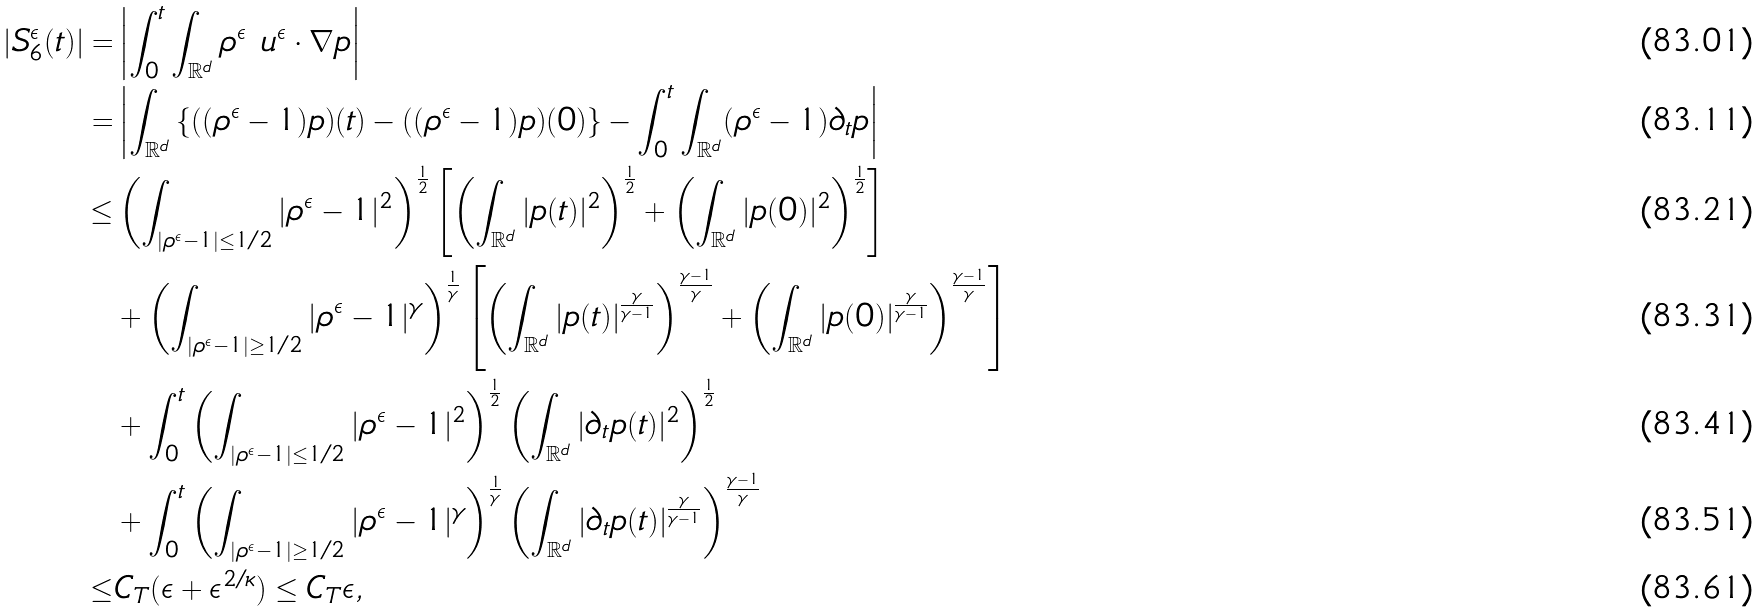<formula> <loc_0><loc_0><loc_500><loc_500>| S ^ { \epsilon } _ { 6 } ( t ) | = & \left | \int ^ { t } _ { 0 } \int _ { \mathbb { R } ^ { d } } \rho ^ { \epsilon } \ u ^ { \epsilon } \cdot \nabla p \right | \\ = & \left | \int _ { \mathbb { R } ^ { d } } \left \{ ( ( \rho ^ { \epsilon } - 1 ) p ) ( t ) - ( ( \rho ^ { \epsilon } - 1 ) p ) ( 0 ) \right \} - \int ^ { t } _ { 0 } \int _ { \mathbb { R } ^ { d } } ( \rho ^ { \epsilon } - 1 ) \partial _ { t } p \right | \\ \leq & \left ( \int _ { | \rho ^ { \epsilon } - 1 | \leq 1 / 2 } | \rho ^ { \epsilon } - 1 | ^ { 2 } \right ) ^ { \frac { 1 } { 2 } } \left [ \left ( \int _ { \mathbb { R } ^ { d } } | p ( t ) | ^ { 2 } \right ) ^ { \frac { 1 } { 2 } } + \left ( \int _ { \mathbb { R } ^ { d } } | p ( 0 ) | ^ { 2 } \right ) ^ { \frac { 1 } { 2 } } \right ] \\ & + \left ( \int _ { | \rho ^ { \epsilon } - 1 | \geq 1 / 2 } | \rho ^ { \epsilon } - 1 | ^ { \gamma } \right ) ^ { \frac { 1 } { \gamma } } \left [ \left ( \int _ { \mathbb { R } ^ { d } } | p ( t ) | ^ { \frac { \gamma } { \gamma - 1 } } \right ) ^ { \frac { \gamma - 1 } { \gamma } } + \left ( \int _ { \mathbb { R } ^ { d } } | p ( 0 ) | ^ { \frac { \gamma } { \gamma - 1 } } \right ) ^ { \frac { \gamma - 1 } { \gamma } } \right ] \\ & + \int ^ { t } _ { 0 } \left ( \int _ { | \rho ^ { \epsilon } - 1 | \leq 1 / 2 } | \rho ^ { \epsilon } - 1 | ^ { 2 } \right ) ^ { \frac { 1 } { 2 } } \left ( \int _ { \mathbb { R } ^ { d } } | \partial _ { t } p ( t ) | ^ { 2 } \right ) ^ { \frac { 1 } { 2 } } \\ & + \int ^ { t } _ { 0 } \left ( \int _ { | \rho ^ { \epsilon } - 1 | \geq 1 / 2 } | \rho ^ { \epsilon } - 1 | ^ { \gamma } \right ) ^ { { \frac { 1 } { \gamma } } } \left ( \int _ { \mathbb { R } ^ { d } } | \partial _ { t } p ( t ) | ^ { \frac { \gamma } { \gamma - 1 } } \right ) ^ { { \frac { \gamma - 1 } { \gamma } } } \\ \leq & C _ { T } ( \epsilon + \epsilon ^ { 2 / \kappa } ) \leq C _ { T } \epsilon ,</formula> 